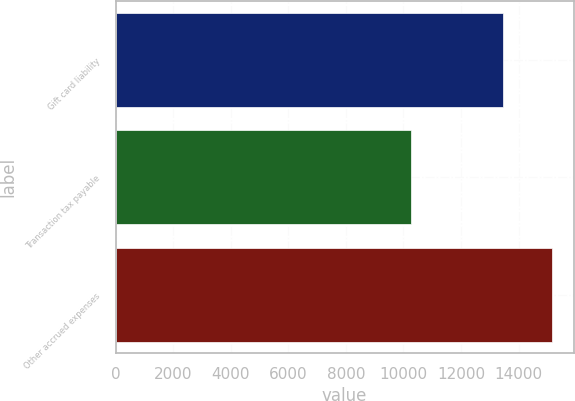<chart> <loc_0><loc_0><loc_500><loc_500><bar_chart><fcel>Gift card liability<fcel>Transaction tax payable<fcel>Other accrued expenses<nl><fcel>13456<fcel>10280<fcel>15156<nl></chart> 